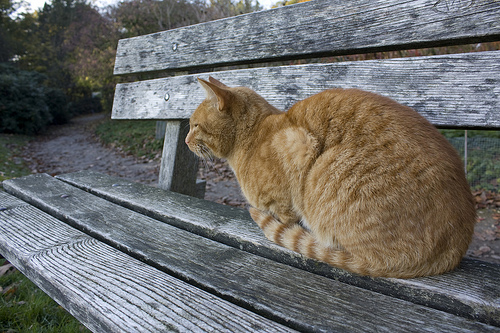What is the color of this cat? The cat is gold in color. 